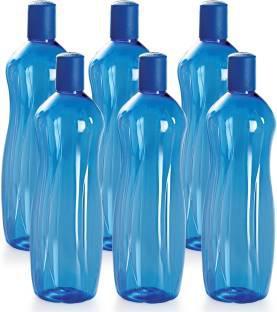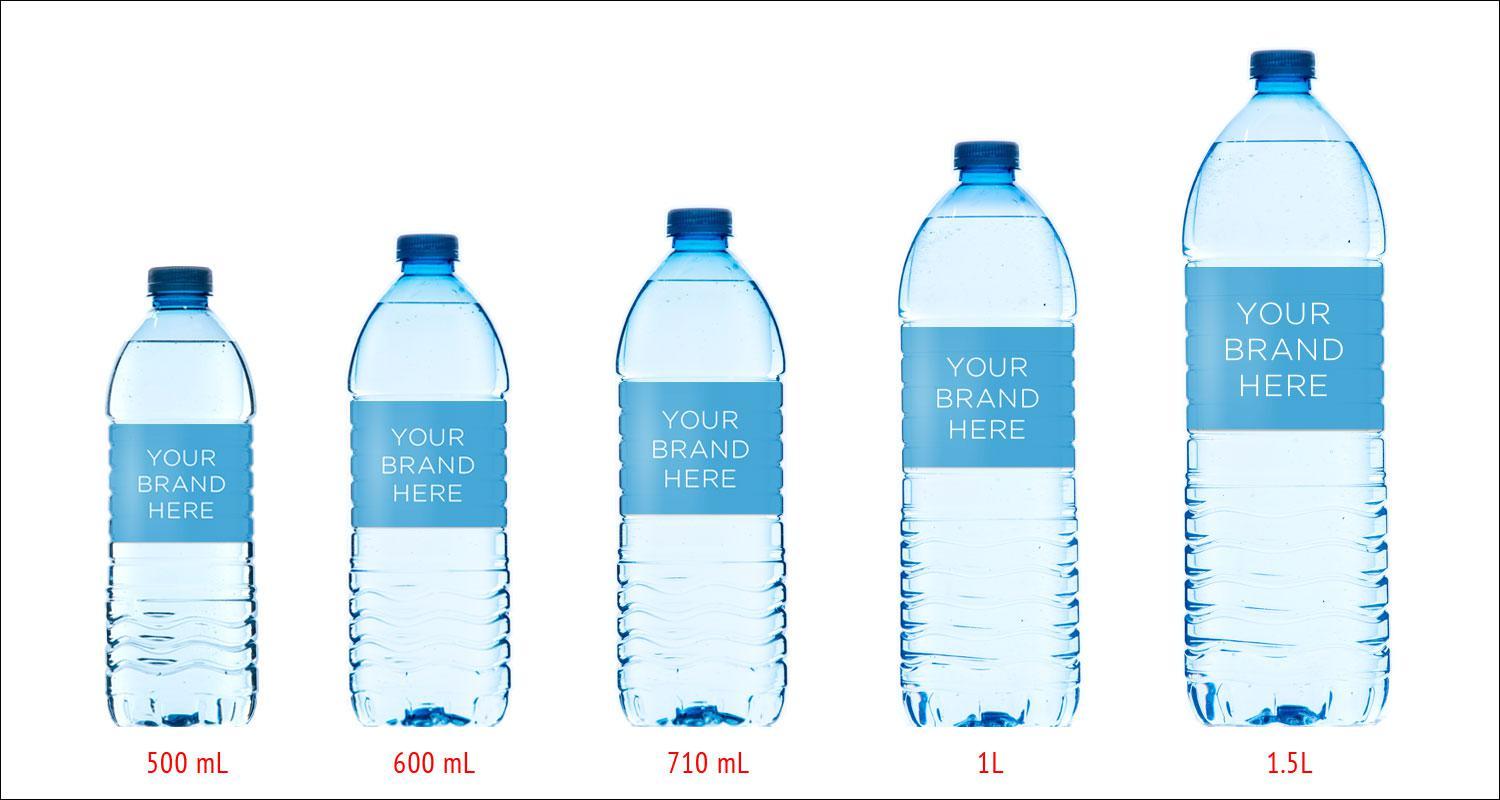The first image is the image on the left, the second image is the image on the right. Given the left and right images, does the statement "In the image on the left, all of the bottle are the same size." hold true? Answer yes or no. Yes. The first image is the image on the left, the second image is the image on the right. Evaluate the accuracy of this statement regarding the images: "Each image shows at least five water bottles arranged in an overlapping formation.". Is it true? Answer yes or no. No. 